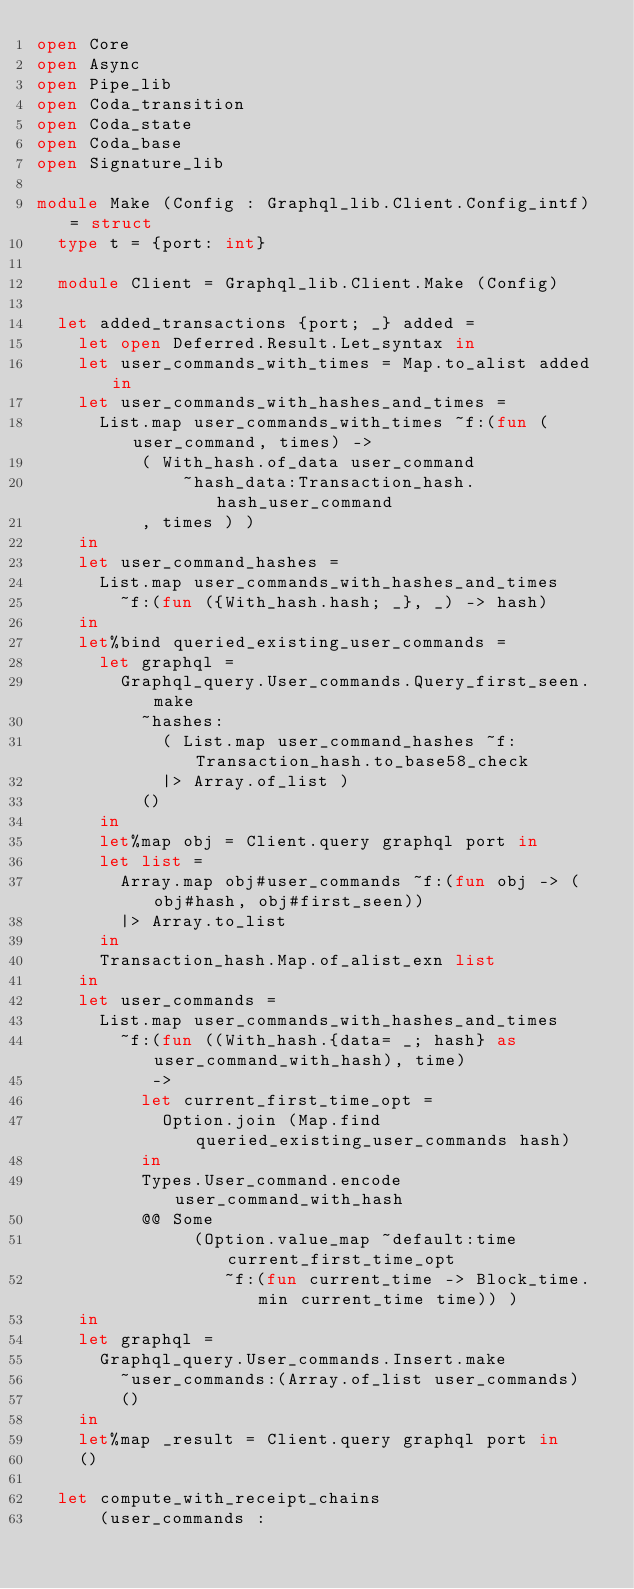<code> <loc_0><loc_0><loc_500><loc_500><_OCaml_>open Core
open Async
open Pipe_lib
open Coda_transition
open Coda_state
open Coda_base
open Signature_lib

module Make (Config : Graphql_lib.Client.Config_intf) = struct
  type t = {port: int}

  module Client = Graphql_lib.Client.Make (Config)

  let added_transactions {port; _} added =
    let open Deferred.Result.Let_syntax in
    let user_commands_with_times = Map.to_alist added in
    let user_commands_with_hashes_and_times =
      List.map user_commands_with_times ~f:(fun (user_command, times) ->
          ( With_hash.of_data user_command
              ~hash_data:Transaction_hash.hash_user_command
          , times ) )
    in
    let user_command_hashes =
      List.map user_commands_with_hashes_and_times
        ~f:(fun ({With_hash.hash; _}, _) -> hash)
    in
    let%bind queried_existing_user_commands =
      let graphql =
        Graphql_query.User_commands.Query_first_seen.make
          ~hashes:
            ( List.map user_command_hashes ~f:Transaction_hash.to_base58_check
            |> Array.of_list )
          ()
      in
      let%map obj = Client.query graphql port in
      let list =
        Array.map obj#user_commands ~f:(fun obj -> (obj#hash, obj#first_seen))
        |> Array.to_list
      in
      Transaction_hash.Map.of_alist_exn list
    in
    let user_commands =
      List.map user_commands_with_hashes_and_times
        ~f:(fun ((With_hash.{data= _; hash} as user_command_with_hash), time)
           ->
          let current_first_time_opt =
            Option.join (Map.find queried_existing_user_commands hash)
          in
          Types.User_command.encode user_command_with_hash
          @@ Some
               (Option.value_map ~default:time current_first_time_opt
                  ~f:(fun current_time -> Block_time.min current_time time)) )
    in
    let graphql =
      Graphql_query.User_commands.Insert.make
        ~user_commands:(Array.of_list user_commands)
        ()
    in
    let%map _result = Client.query graphql port in
    ()

  let compute_with_receipt_chains
      (user_commands :</code> 